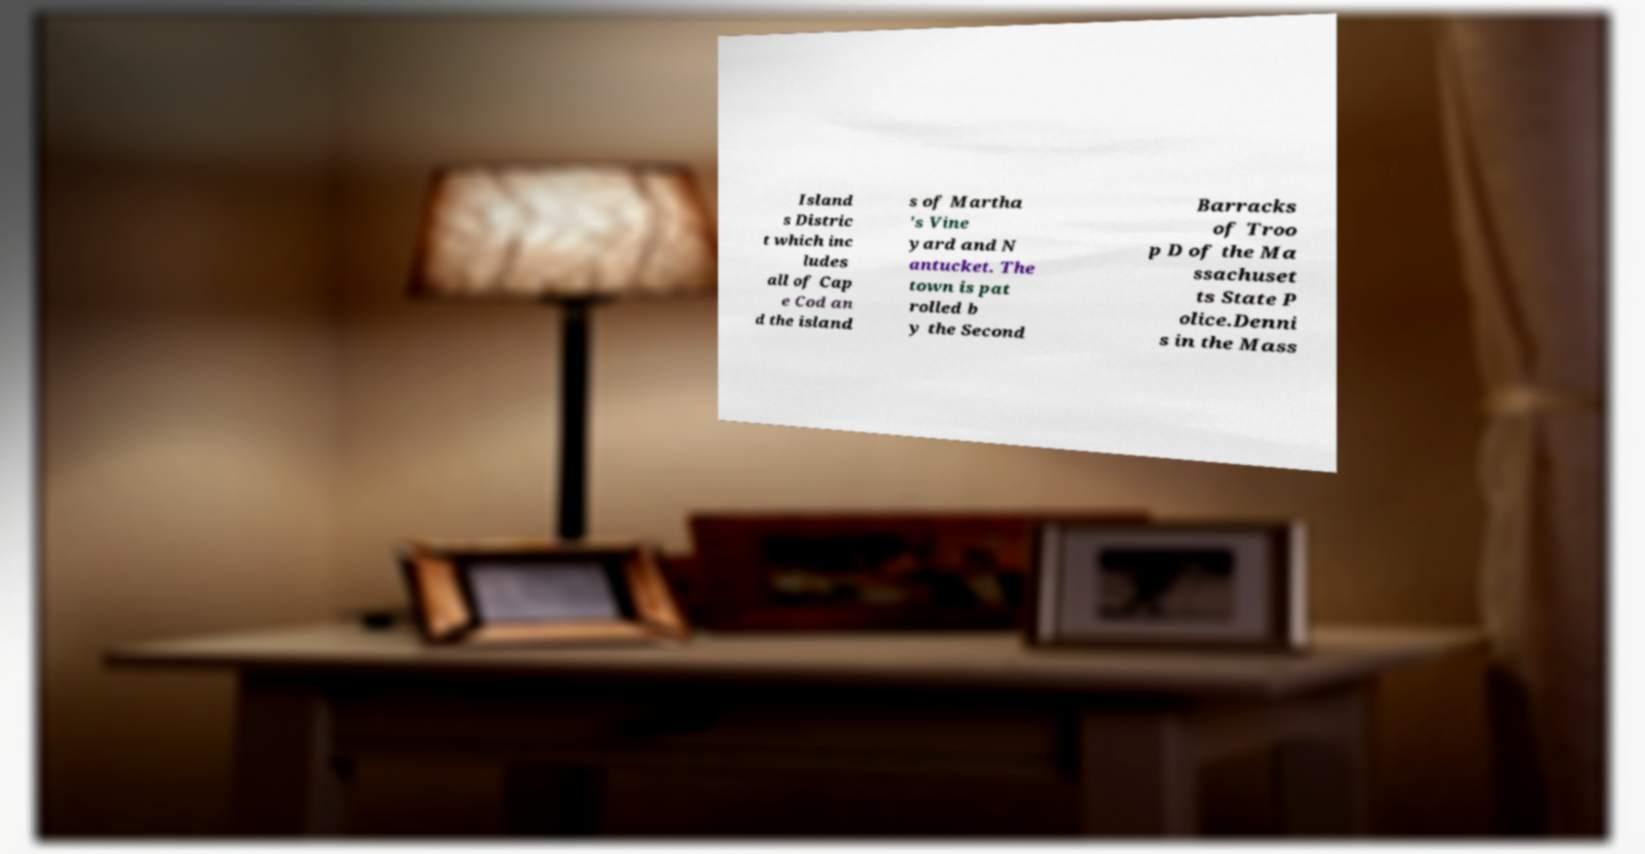What messages or text are displayed in this image? I need them in a readable, typed format. Island s Distric t which inc ludes all of Cap e Cod an d the island s of Martha 's Vine yard and N antucket. The town is pat rolled b y the Second Barracks of Troo p D of the Ma ssachuset ts State P olice.Denni s in the Mass 